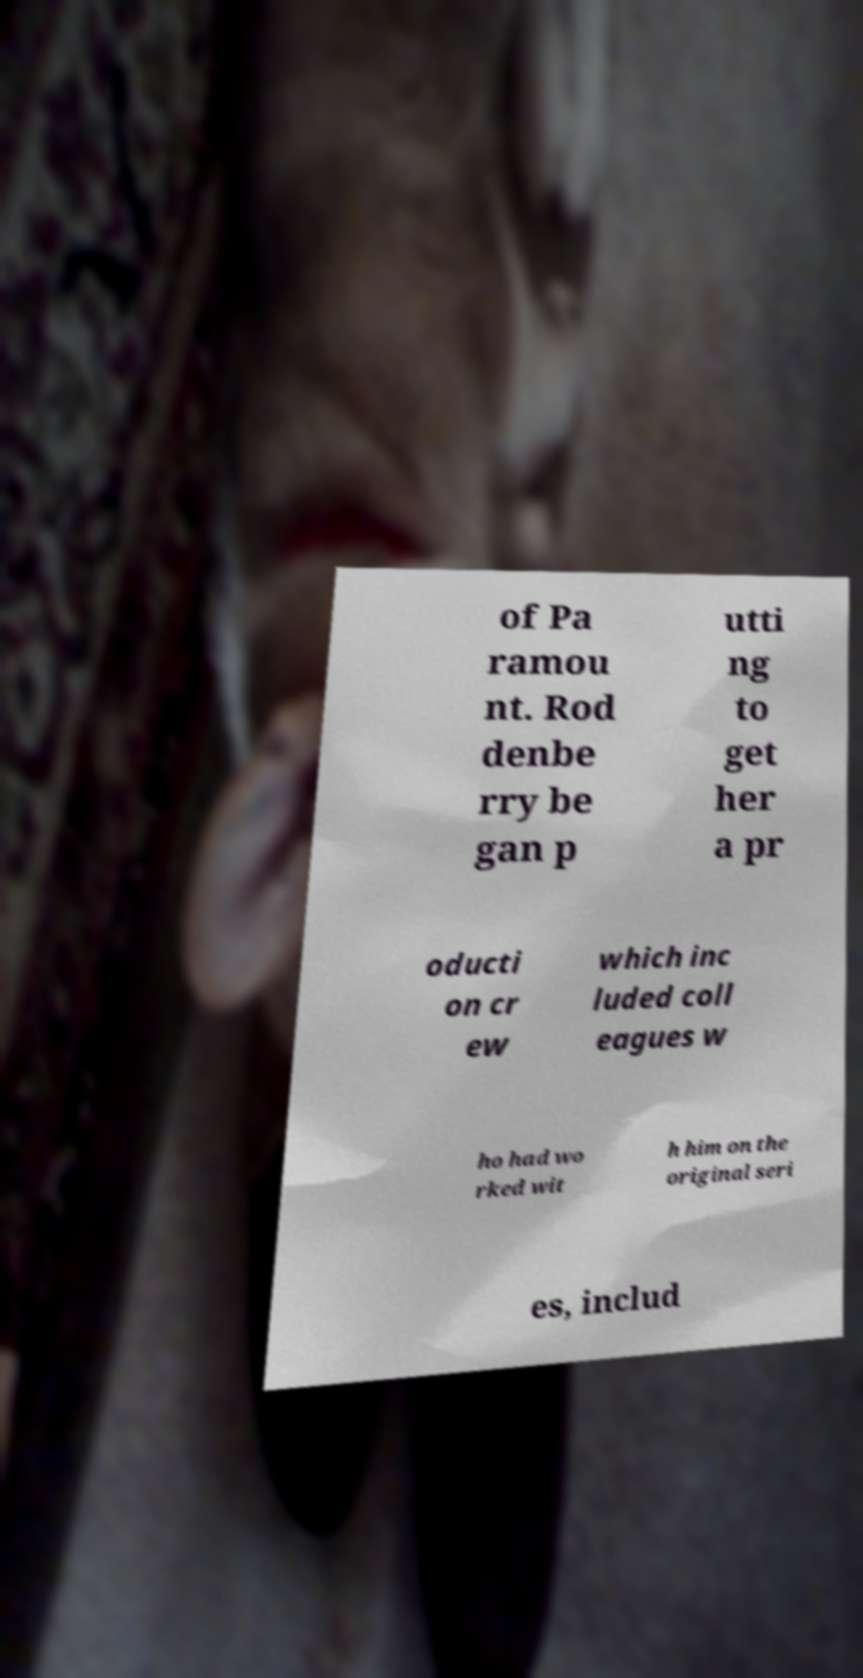Could you extract and type out the text from this image? of Pa ramou nt. Rod denbe rry be gan p utti ng to get her a pr oducti on cr ew which inc luded coll eagues w ho had wo rked wit h him on the original seri es, includ 